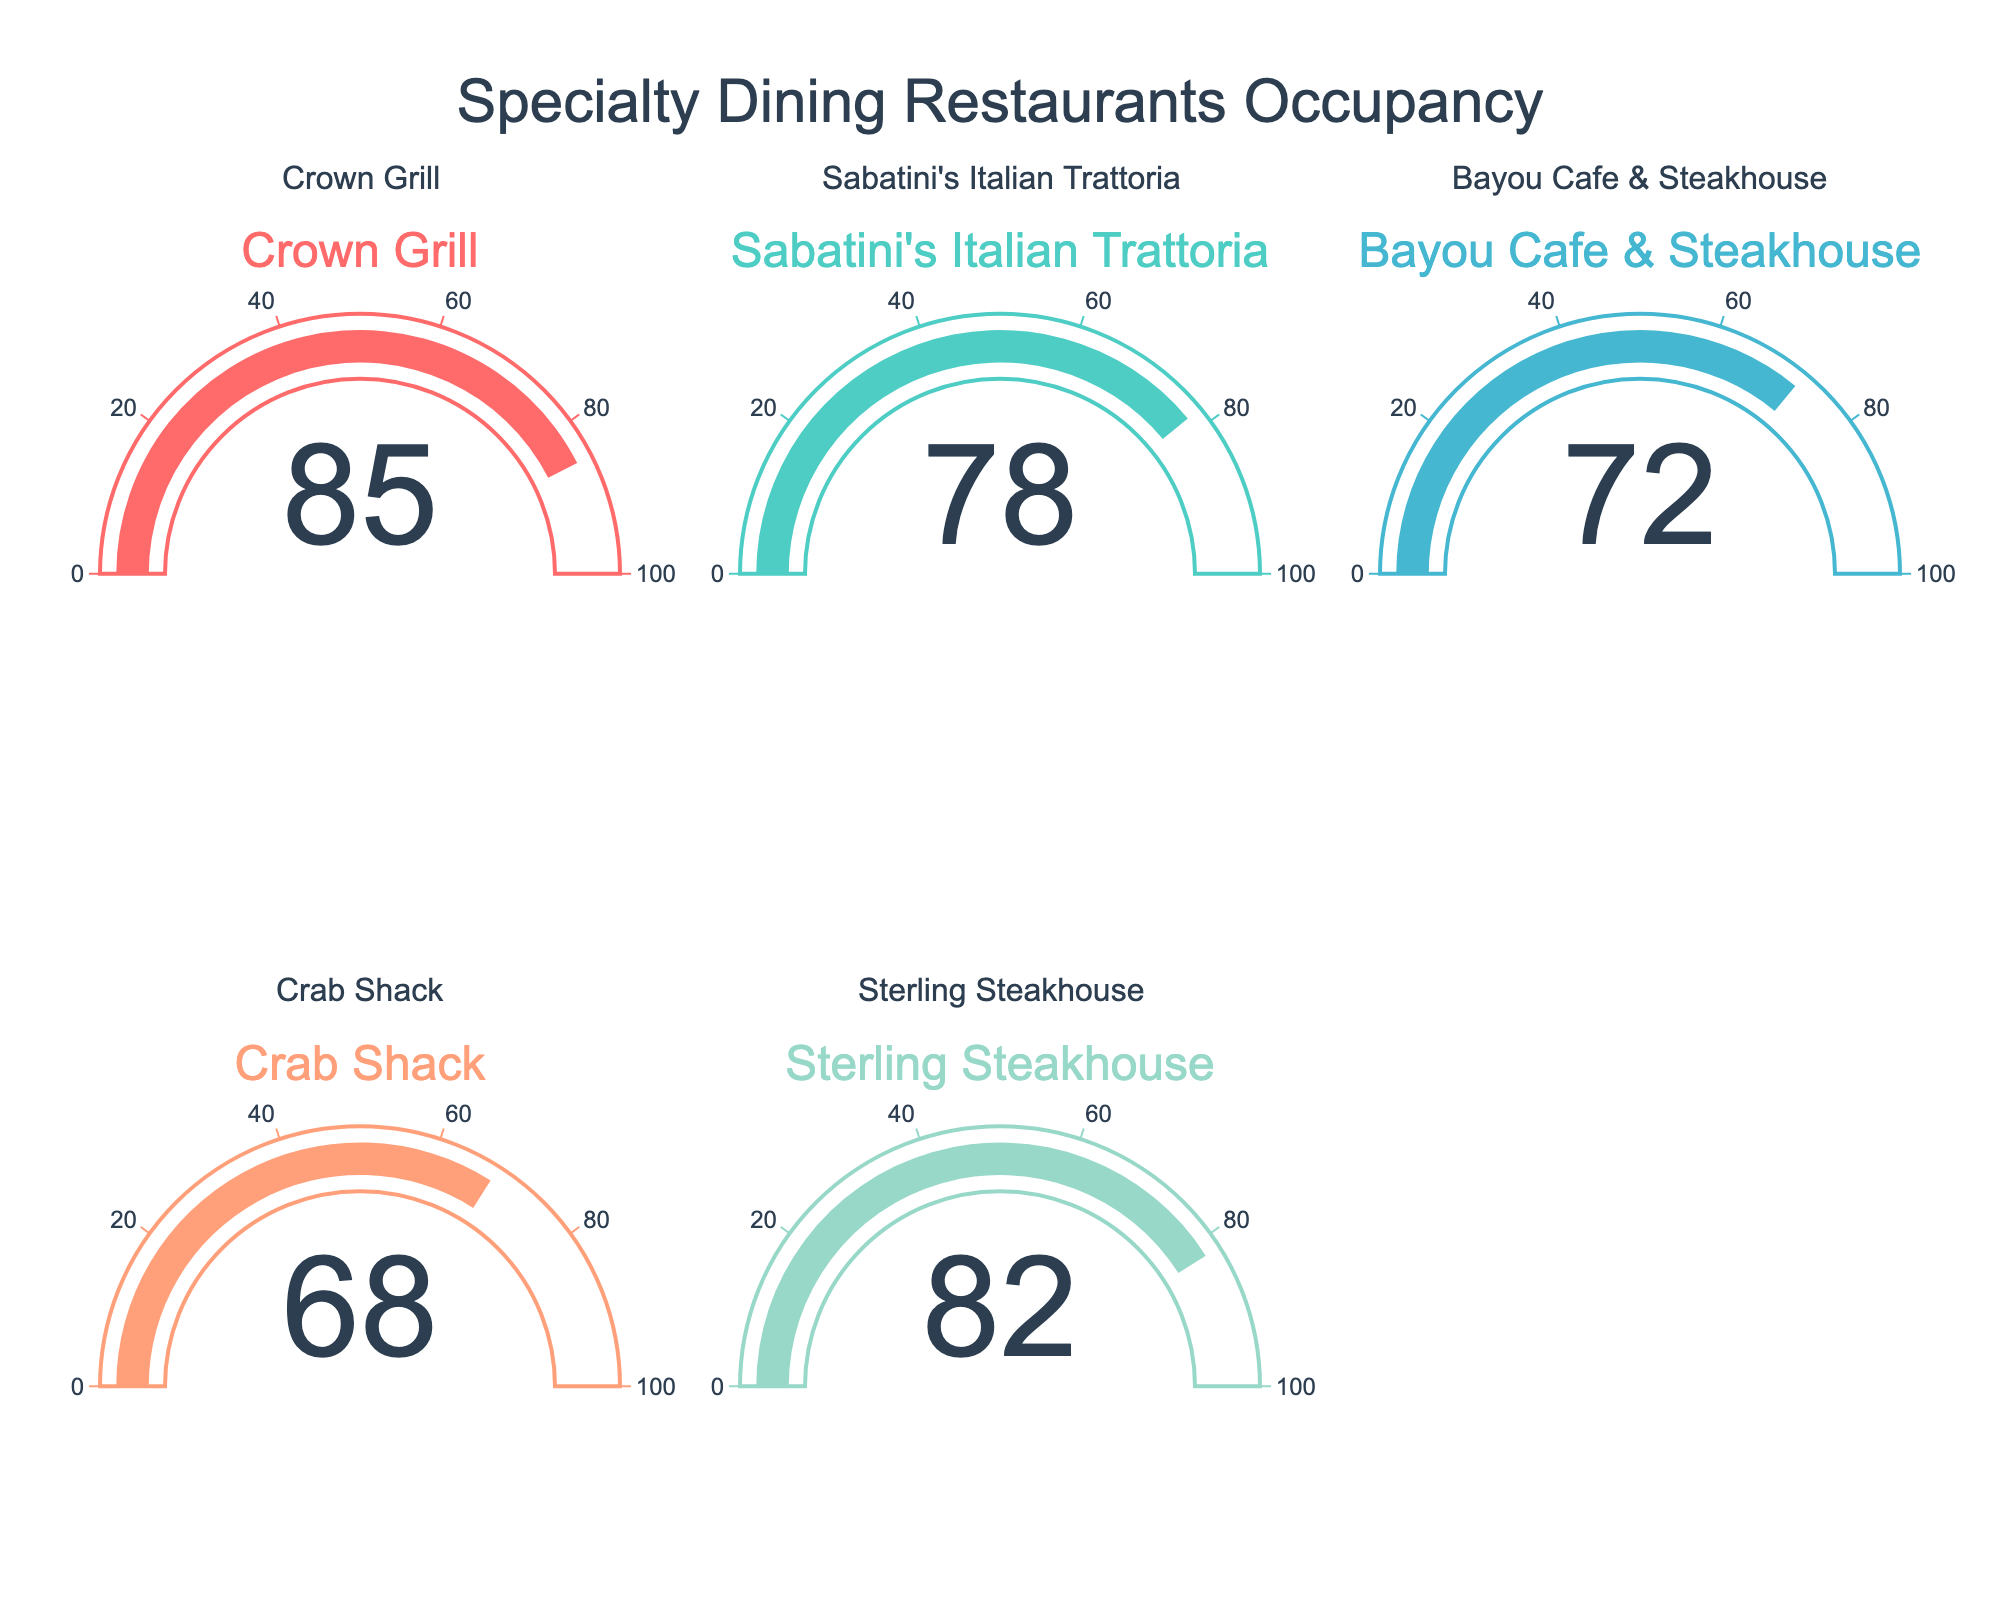What is the title of the chart? The title is placed at the top center of the chart in a prominent font. It states the overall subject of the chart.
Answer: Specialty Dining Restaurants Occupancy How many restaurants have an occupancy rate above 75%? Count the number of gauges indicating a percentage above 75. Crown Grill, Sabatini's Italian Trattoria, and Sterling Steakhouse are above 75%.
Answer: 3 Which restaurant has the highest occupancy rate? Identify the highest value displayed on any of the gauges. The Crown Grill gauge shows 85%.
Answer: Crown Grill Compare the occupancy rates of Sabatini's Italian Trattoria and Bayou Cafe & Steakhouse. Which one is higher, and by how much? Sabatini's Italian Trattoria has a rate of 78%, while Bayou Cafe & Steakhouse has 72%. Subtract the lower rate from the higher one. 78 - 72 = 6.
Answer: Sabatini's Italian Trattoria by 6% Which restaurant has the lowest occupancy rate? Find the gauge displaying the lowest value. The Crab Shack shows 68%.
Answer: Crab Shack What is the average occupancy rate of all the restaurants? Add all the occupancy rates and divide by the number of restaurants. (85 + 78 + 72 + 68 + 82) = 385, and 385 / 5 = 77.
Answer: 77% Between Crown Grill and Sterling Steakhouse, which restaurant has a lower occupancy rate? Compare the values of the Crown Grill and Sterling Steakhouse gauges. Crown Grill has 85% and Sterling Steakhouse has 82%.
Answer: Sterling Steakhouse What is the range of occupancy rates across all restaurants? Subtract the lowest rate from the highest rate. Highest is 85% (Crown Grill), and the lowest is 68% (Crab Shack). 85 - 68 = 17.
Answer: 17 Is any restaurant's occupancy rate within the range of 70% to 80%? Check each gauge to see if any values fall between 70% and 80%. Sabatini's Italian Trattoria is at 78% and Bayou Cafe & Steakhouse is at 72%.
Answer: Yes, two restaurants What percentage of restaurants have an occupancy rate below 70%? Determine the number of restaurants below 70% and divide by the total number of restaurants. Only Crab Shack is below 70%. So, 1 out of 5 restaurants, (1/5) * 100 = 20%.
Answer: 20% 